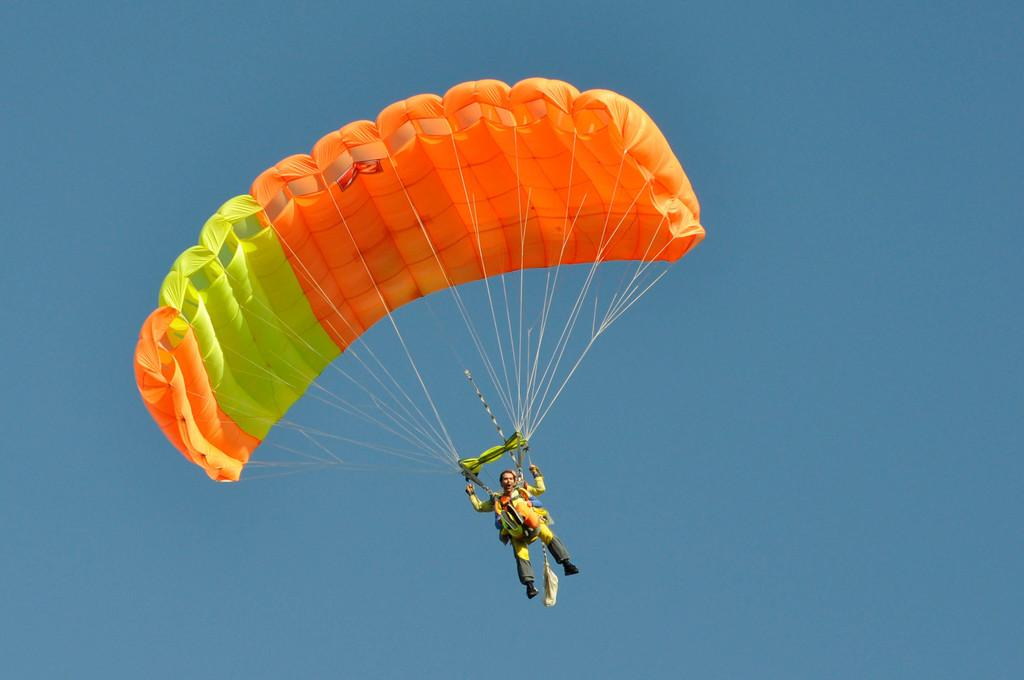What is the man in the image doing? The man is paragliding in the image. What can be seen in the background of the image? The sky is visible in the background of the image. What is the color of the sky in the image? The color of the sky is blue. How many sparks can be seen coming from the stone in the image? There is no stone or spark present in the image. 